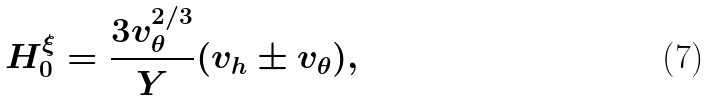Convert formula to latex. <formula><loc_0><loc_0><loc_500><loc_500>H _ { 0 } ^ { \xi } = \frac { 3 v _ { \theta } ^ { 2 / 3 } } { Y } ( v _ { h } \pm v _ { \theta } ) ,</formula> 